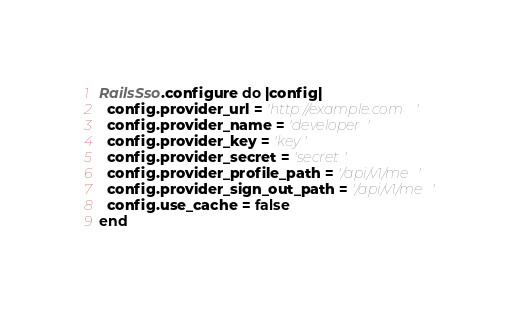<code> <loc_0><loc_0><loc_500><loc_500><_Ruby_>RailsSso.configure do |config|
  config.provider_url = 'http://example.com'
  config.provider_name = 'developer'
  config.provider_key = 'key'
  config.provider_secret = 'secret'
  config.provider_profile_path = '/api/v1/me'
  config.provider_sign_out_path = '/api/v1/me'
  config.use_cache = false
end
</code> 